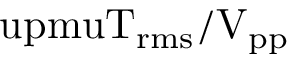<formula> <loc_0><loc_0><loc_500><loc_500>\ u p m u T _ { r m s } / V _ { p p }</formula> 